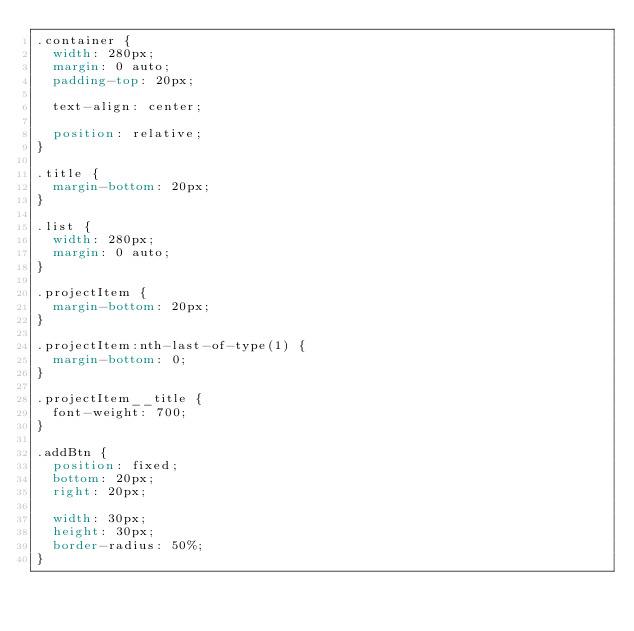Convert code to text. <code><loc_0><loc_0><loc_500><loc_500><_CSS_>.container {
  width: 280px;
  margin: 0 auto;
  padding-top: 20px;

  text-align: center;

  position: relative;
}

.title {
  margin-bottom: 20px;
}

.list {
  width: 280px;
  margin: 0 auto;
}

.projectItem {
  margin-bottom: 20px;
}

.projectItem:nth-last-of-type(1) {
  margin-bottom: 0;
}

.projectItem__title {
  font-weight: 700;
}

.addBtn {
  position: fixed;
  bottom: 20px;
  right: 20px;

  width: 30px;
  height: 30px;
  border-radius: 50%;
}
</code> 